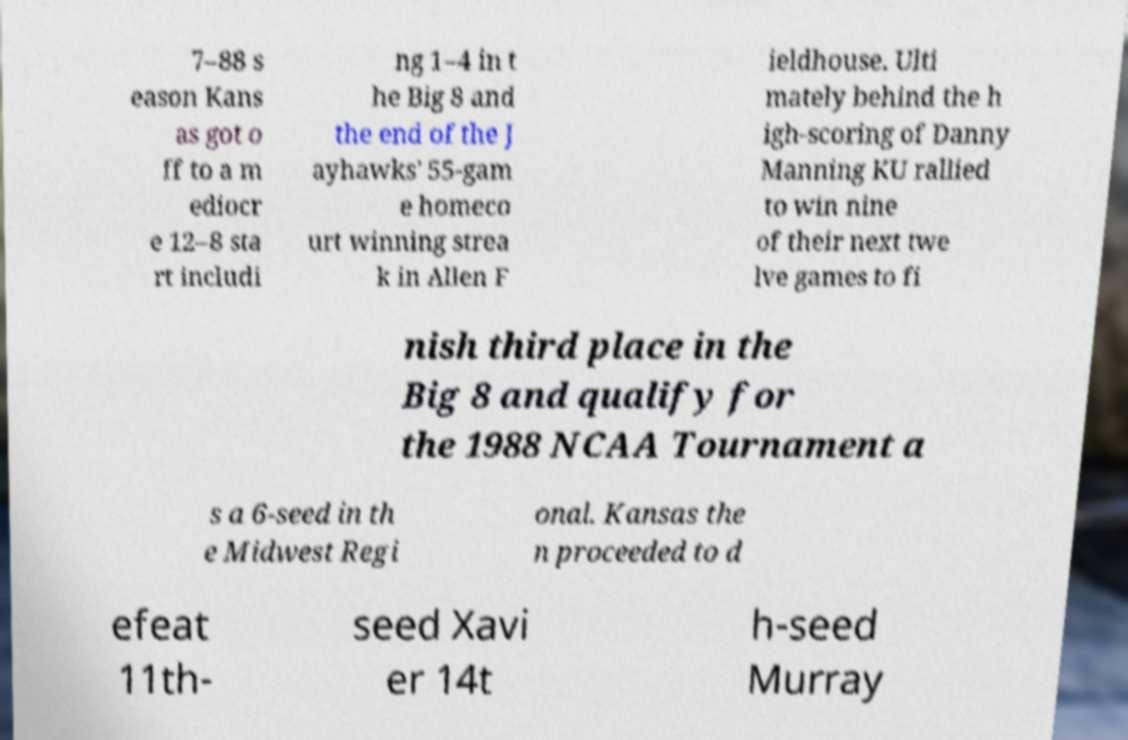Could you assist in decoding the text presented in this image and type it out clearly? 7–88 s eason Kans as got o ff to a m ediocr e 12–8 sta rt includi ng 1–4 in t he Big 8 and the end of the J ayhawks' 55-gam e homeco urt winning strea k in Allen F ieldhouse. Ulti mately behind the h igh-scoring of Danny Manning KU rallied to win nine of their next twe lve games to fi nish third place in the Big 8 and qualify for the 1988 NCAA Tournament a s a 6-seed in th e Midwest Regi onal. Kansas the n proceeded to d efeat 11th- seed Xavi er 14t h-seed Murray 